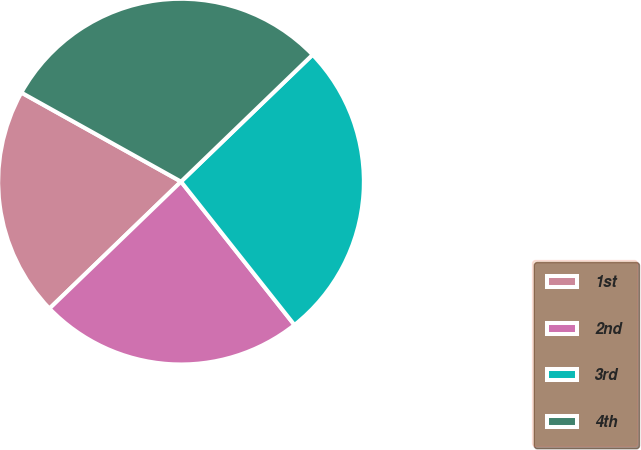Convert chart. <chart><loc_0><loc_0><loc_500><loc_500><pie_chart><fcel>1st<fcel>2nd<fcel>3rd<fcel>4th<nl><fcel>20.31%<fcel>23.44%<fcel>26.56%<fcel>29.69%<nl></chart> 